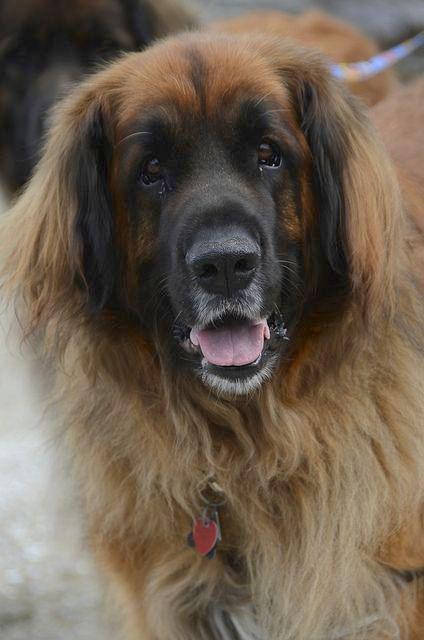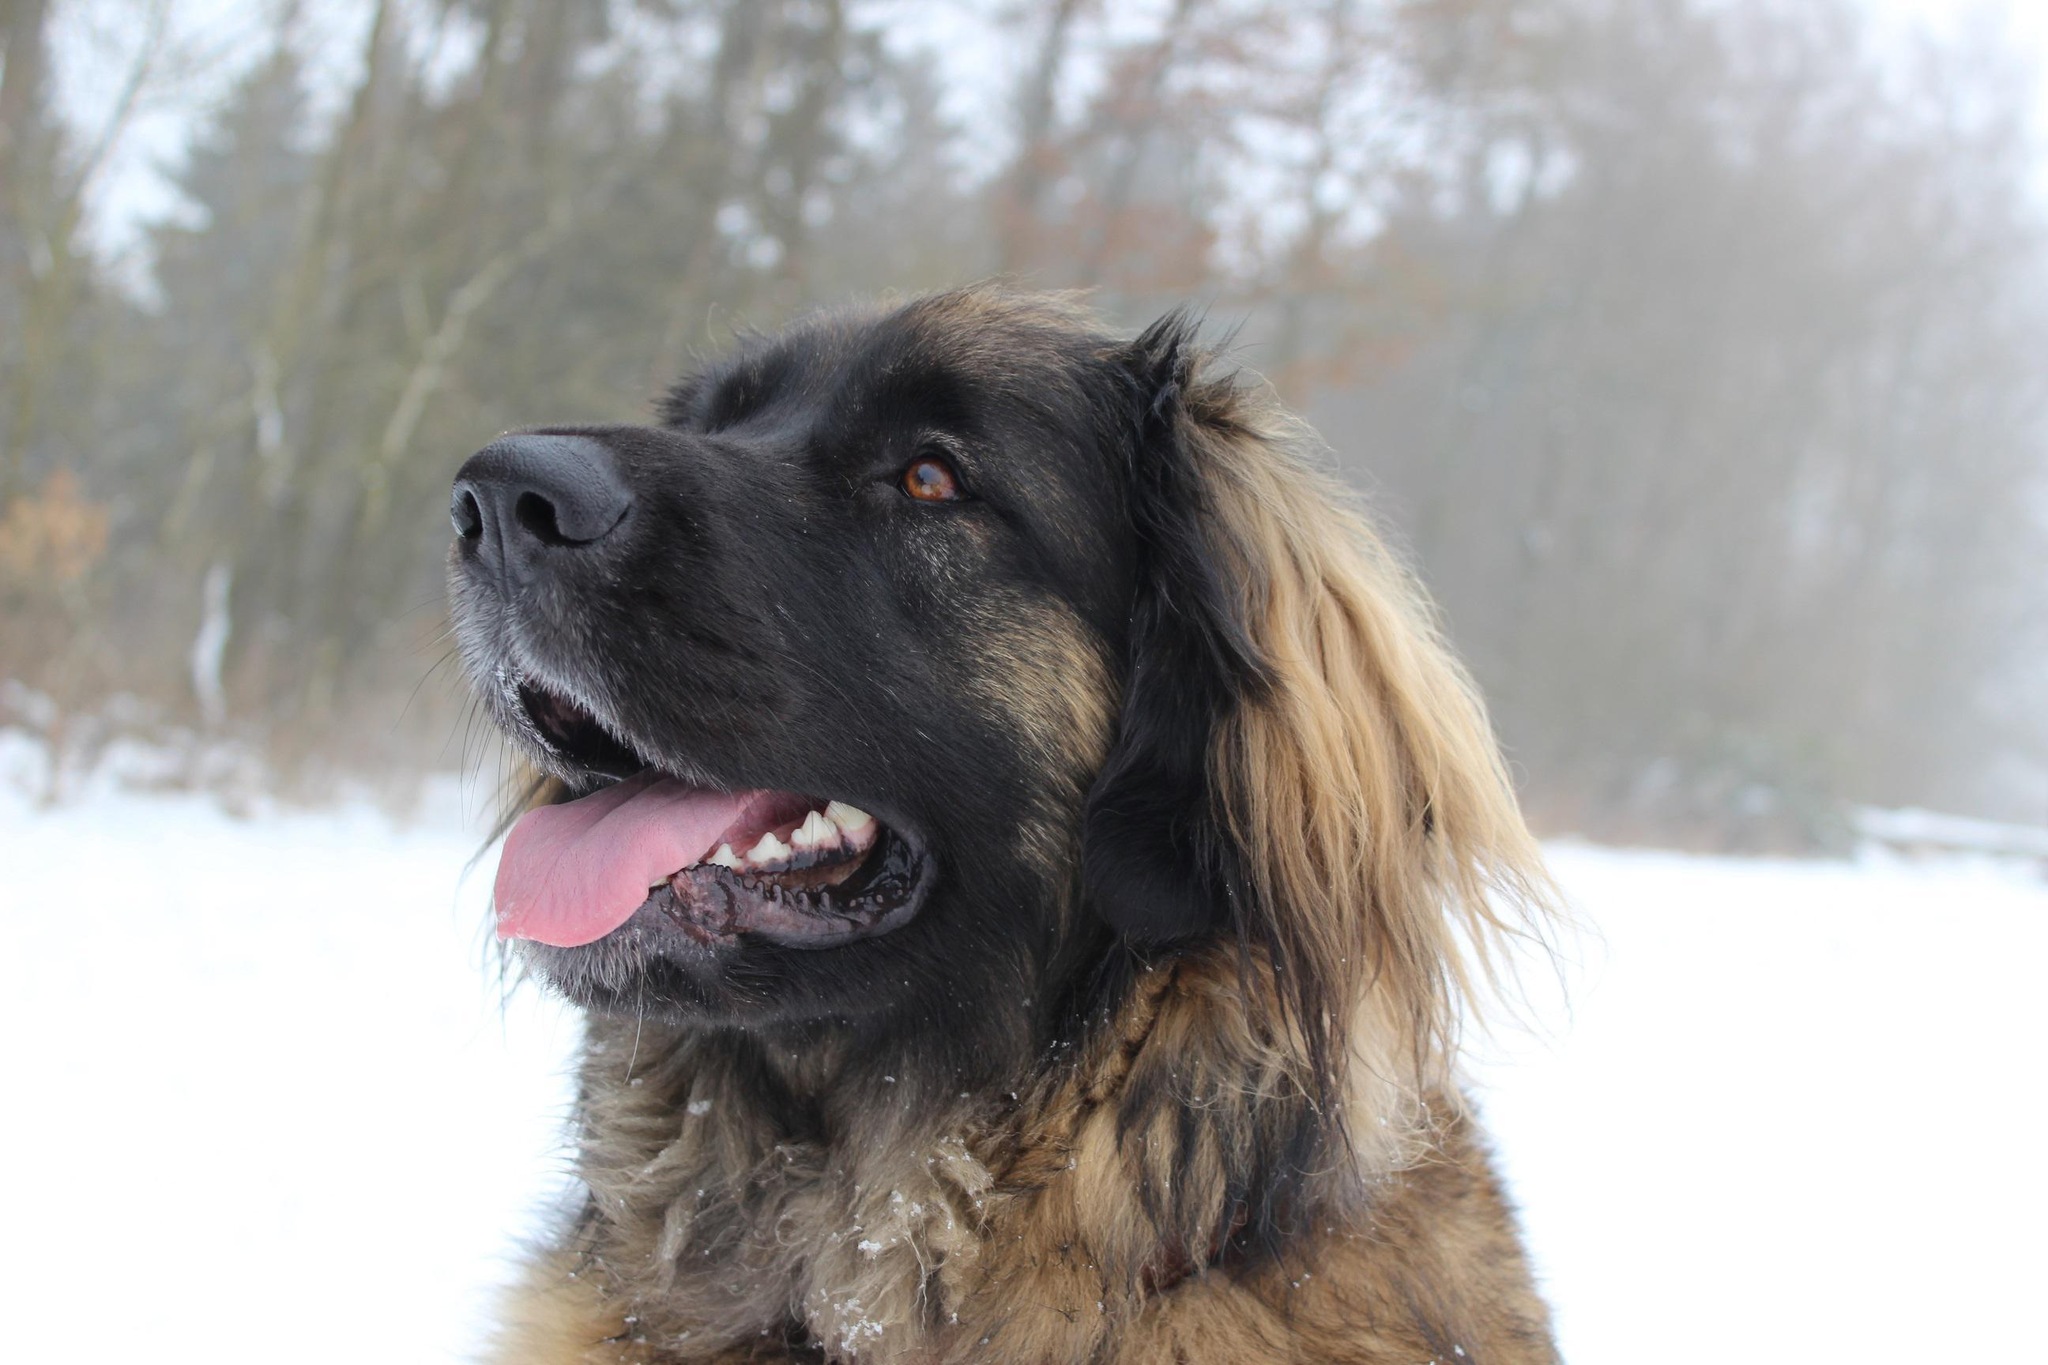The first image is the image on the left, the second image is the image on the right. For the images displayed, is the sentence "A image shows one dog in a snowy outdoor setting." factually correct? Answer yes or no. Yes. The first image is the image on the left, the second image is the image on the right. Assess this claim about the two images: "The dog in one of the images in on grass". Correct or not? Answer yes or no. No. 